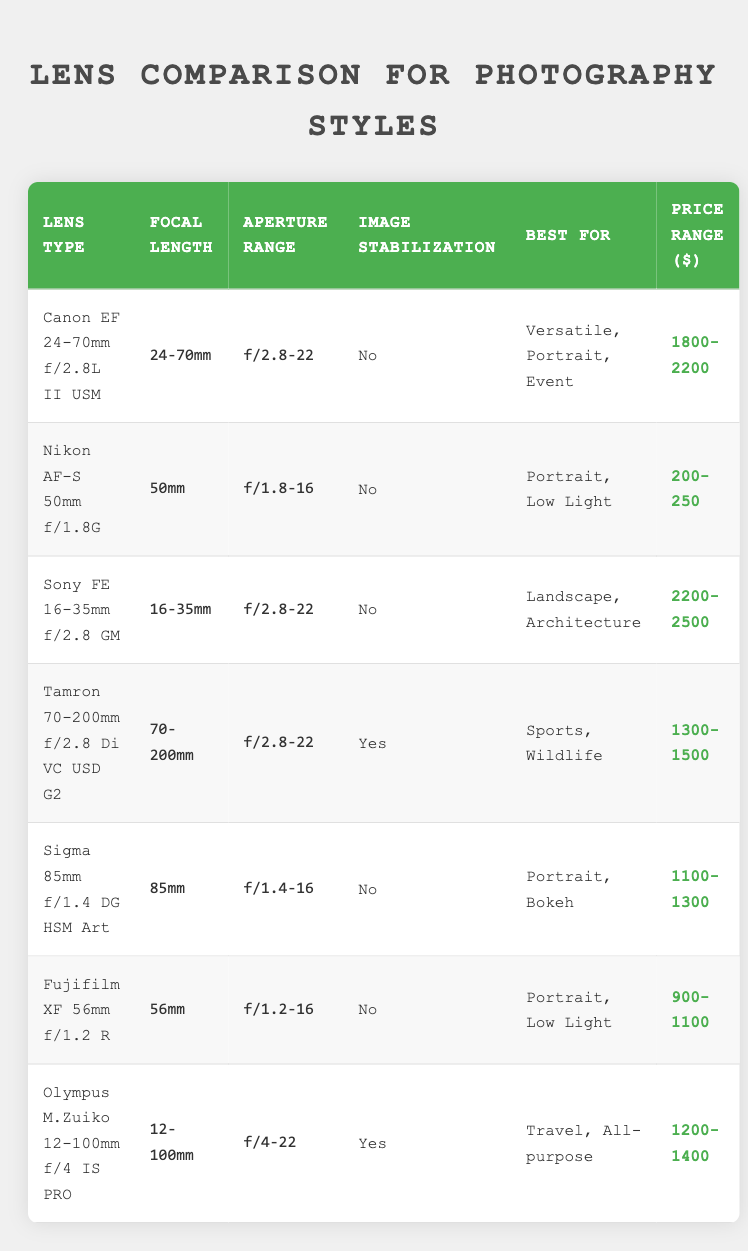What is the focal length range of the Canon EF 24-70mm f/2.8L II USM? The focal length is directly stated in the "Focal Length" column next to the lens type. For the Canon EF 24-70mm f/2.8L II USM, it is listed as "24-70mm."
Answer: 24-70mm What is the aperture range for the Nikon AF-S 50mm f/1.8G? The aperture range is found in the "Aperture Range" column corresponding to the Nikon AF-S 50mm f/1.8G row. It lists the range as "f/1.8-16."
Answer: f/1.8-16 Which lenses have image stabilization? I will look at the "Image Stabilization" column and filter for entries that list "Yes." The lenses with image stabilization are the "Tamron 70-200mm f/2.8 Di VC USD G2" and "Olympus M.Zuiko 12-100mm f/4 IS PRO."
Answer: Tamron 70-200mm f/2.8 Di VC USD G2, Olympus M.Zuiko 12-100mm f/4 IS PRO What is the price range for Sony FE 16-35mm f/2.8 GM? The price range is found in the table under the "Price Range ($)" column corresponding to the Sony FE 16-35mm f/2.8 GM. In the table, it is given as "2200-2500."
Answer: 2200-2500 How many lenses are best for portrait photography based on the table? I will first identify the lenses that specify "Portrait" in the "Best For" column. The lenses that fall under this category are "Canon EF 24-70mm f/2.8L II USM," "Sigma 85mm f/1.4 DG HSM Art," "Nikon AF-S 50mm f/1.8G," and "Fujifilm XF 56mm f/1.2 R." There are four lenses that are best for portrait photography.
Answer: 4 Is the focal length of the Tamron 70-200mm f/2.8 Di VC USD G2 greater than that of the Fujifilm XF 56mm f/1.2 R? The focal length of the Tamron 70-200mm f/2.8 Di VC USD G2 is "70-200mm," and for the Fujifilm XF 56mm f/1.2 R, it is "56mm." Since the range 70-200mm surpasses 56mm, the statement is true.
Answer: Yes What is the median price range of the lenses listed? To find the median price, I will list the inner values of the price range: 200-250, 900-1100, 1100-1300, 1300-1500, 1800-2200, 2200-2500. First, convert these to numeric values and find their average. The median values fall at middle two ranges, being 1100-1300 and 1300-1500, so the median range is around 1100-1500.
Answer: 1100-1500 Which lens is best for travel photography and how much does it cost? The "Best For" column lists "Travel, All-purpose" under the "Olympus M.Zuiko 12-100mm f/4 IS PRO." Therefore, the price range for this lens can be found in the "Price Range ($)" column, which is "1200-1400."
Answer: Olympus M.Zuiko 12-100mm f/4 IS PRO, 1200-1400 What is the best lens for sports photography? I will check the "Best For" column and look for "Sports." The lens identified as best for sports photography is "Tamron 70-200mm f/2.8 Di VC USD G2."
Answer: Tamron 70-200mm f/2.8 Di VC USD G2 